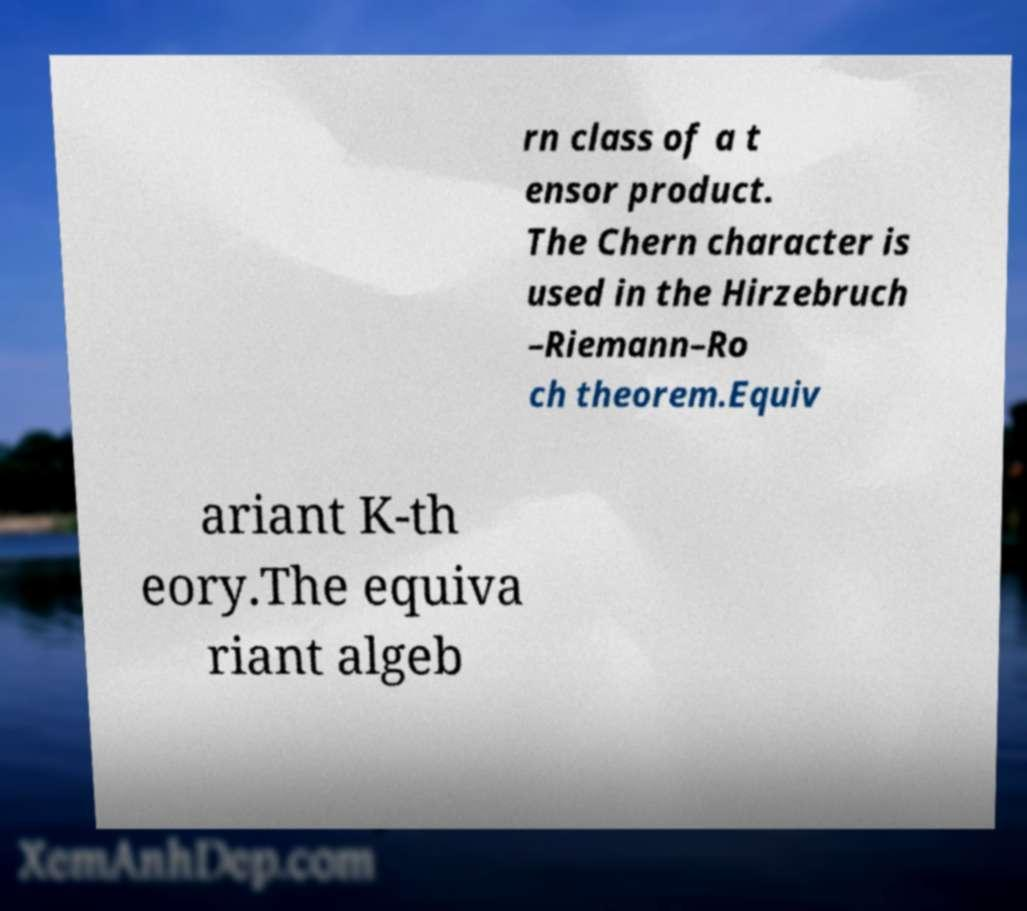For documentation purposes, I need the text within this image transcribed. Could you provide that? rn class of a t ensor product. The Chern character is used in the Hirzebruch –Riemann–Ro ch theorem.Equiv ariant K-th eory.The equiva riant algeb 